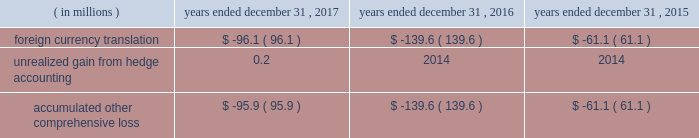Table of contents cdw corporation and subsidiaries method or straight-line method , as applicable .
The company classifies deferred financing costs as a direct deduction from the carrying value of the long-term debt liability on the consolidated balance sheets , except for deferred financing costs associated with revolving credit facilities which are presented as an asset , within other assets on the consolidated balance sheets .
Derivative instruments the company has interest rate cap agreements for the purpose of hedging its exposure to fluctuations in interest rates .
The interest rate cap agreements are designated as cash flow hedges of interest rate risk and recorded at fair value in other assets on the consolidated balance sheets .
The gain or loss on the derivative instruments is reported as a component of accumulated other comprehensive loss until reclassified to interest expense in the same period the hedge transaction affects earnings .
Fair value measurements fair value is defined under gaap as the price that would be received to sell an asset or paid to transfer a liability in an orderly transaction between market participants at the measurement date .
A fair value hierarchy has been established for valuation inputs to prioritize the inputs into three levels based on the extent to which inputs used in measuring fair value are observable in the market .
Each fair value measurement is reported in one of the three levels which is determined by the lowest level input that is significant to the fair value measurement in its entirety .
These levels are : level 1 2013 observable inputs such as quoted prices for identical instruments traded in active markets .
Level 2 2013 inputs are based on quoted prices for similar instruments in active markets , quoted prices for identical or similar instruments in markets that are not active and model-based valuation techniques for which all significant assumptions are observable in the market or can be corroborated by observable market data for substantially the full term of the assets or liabilities .
Level 3 2013 inputs are generally unobservable and typically reflect management 2019s estimates of assumptions that market participants would use in pricing the asset or liability .
The fair values are therefore determined using model-based techniques that include option pricing models , discounted cash flow models and similar techniques .
Accumulated other comprehensive loss the components of accumulated other comprehensive loss included in stockholders 2019 equity are as follows: .
Revenue recognition the company is a primary distribution channel for a large group of vendors and suppliers , including original equipment manufacturers ( 201coems 201d ) , software publishers , wholesale distributors and cloud providers .
The company records revenue from sales transactions when title and risk of loss are passed to the customer , there is persuasive evidence of an arrangement for sale , delivery has occurred and/or services have been rendered , the sales price is fixed or determinable , and collectability is reasonably assured .
The company 2019s shipping terms typically specify f.o.b .
Destination , at which time title and risk of loss have passed to the customer .
Revenues from the sales of hardware products and software licenses are generally recognized on a gross basis with the selling price to the customer recorded as sales and the acquisition cost of the product recorded as cost of sales .
These items can be delivered to customers in a variety of ways , including ( i ) as physical product shipped from the company 2019s warehouse , ( ii ) via drop-shipment by the vendor or supplier , or ( iii ) via electronic delivery for software licenses .
At the time of sale , the company records an estimate for sales returns and allowances based on historical experience .
The company 2019s vendor partners warrant most of the products the company sells .
The company leverages drop-shipment arrangements with many of its vendors and suppliers to deliver products to its customers without having to physically hold the inventory at its warehouses , thereby increasing efficiency and reducing .
What was the three year total accumulated other comprehensive loss in millions? 
Computations: table_sum(accumulated other comprehensive loss, none)
Answer: -296.6. 